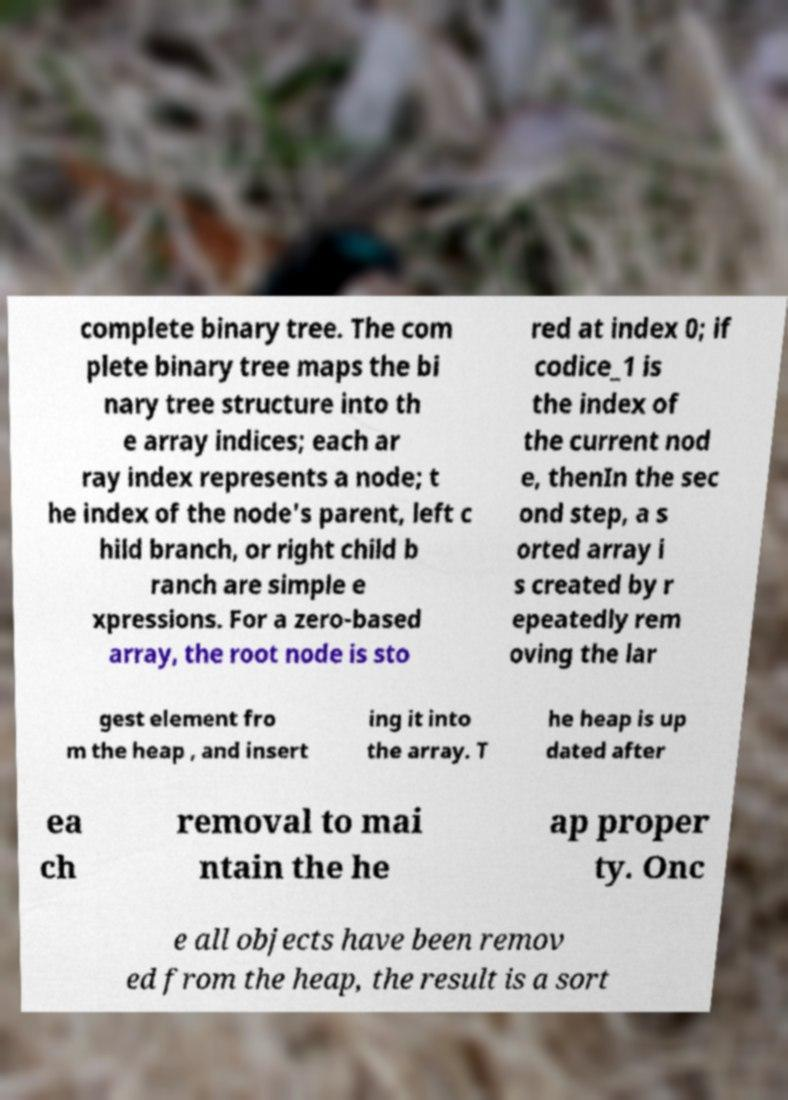Please read and relay the text visible in this image. What does it say? complete binary tree. The com plete binary tree maps the bi nary tree structure into th e array indices; each ar ray index represents a node; t he index of the node's parent, left c hild branch, or right child b ranch are simple e xpressions. For a zero-based array, the root node is sto red at index 0; if codice_1 is the index of the current nod e, thenIn the sec ond step, a s orted array i s created by r epeatedly rem oving the lar gest element fro m the heap , and insert ing it into the array. T he heap is up dated after ea ch removal to mai ntain the he ap proper ty. Onc e all objects have been remov ed from the heap, the result is a sort 